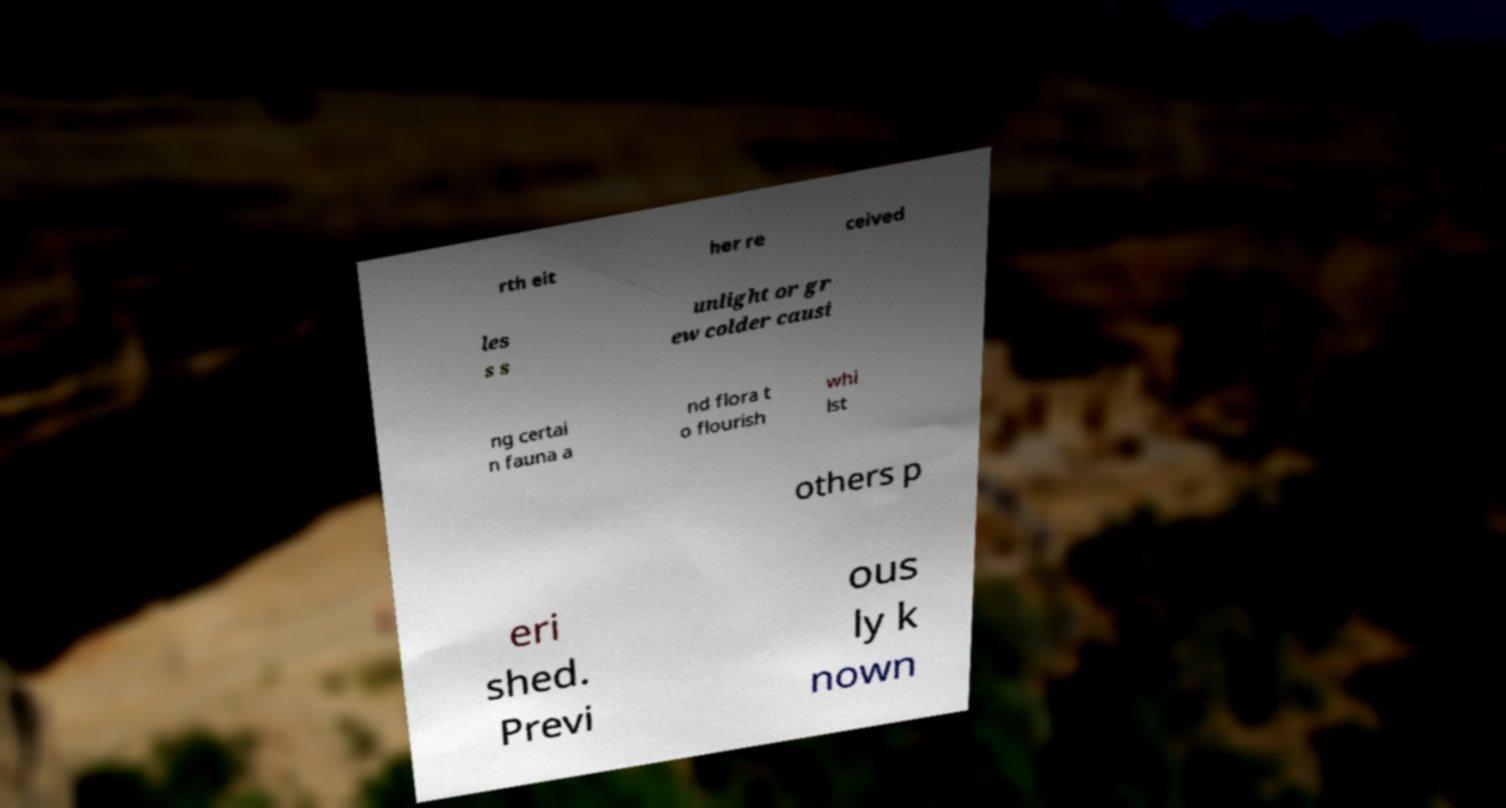For documentation purposes, I need the text within this image transcribed. Could you provide that? rth eit her re ceived les s s unlight or gr ew colder causi ng certai n fauna a nd flora t o flourish whi lst others p eri shed. Previ ous ly k nown 